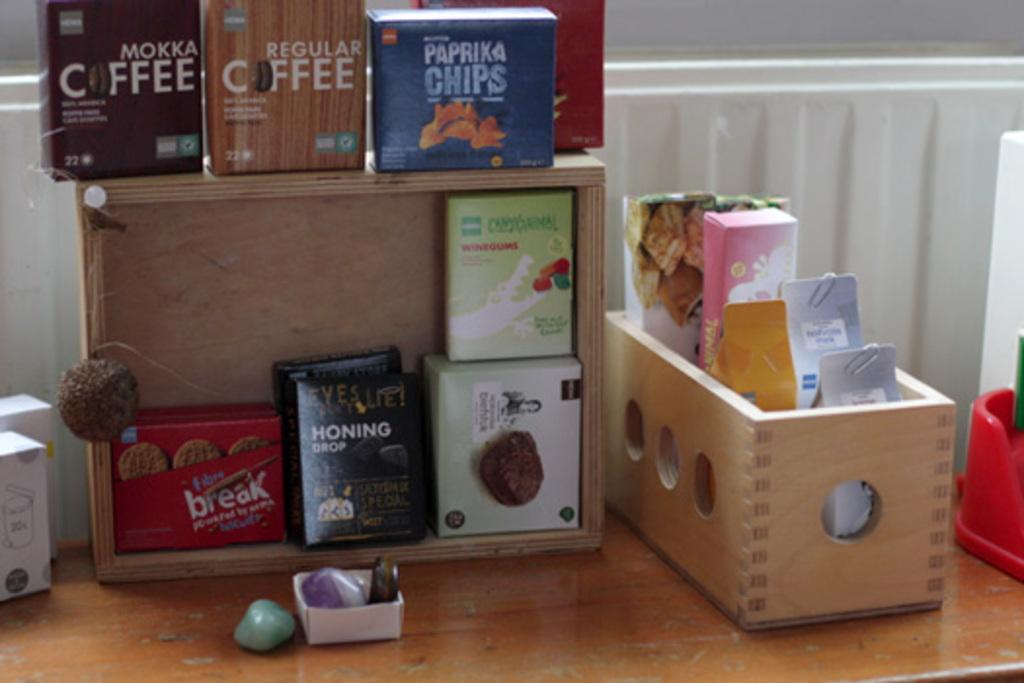What type of objects can be seen in the image? There are boxes, items with paper clips, and stones in the image. How many items with paper clips are visible? There are three items with paper clips in the image. What else can be found on the table in the image? There are other objects on the table in the image. What is visible in the background of the image? There is a wall in the background of the image. What type of bait is used to catch the pet in the image? There is no bait or pet present in the image. What type of skin is visible on the objects in the image? The objects in the image do not have skin; they are inanimate objects such as boxes, paper clips, and stones. 